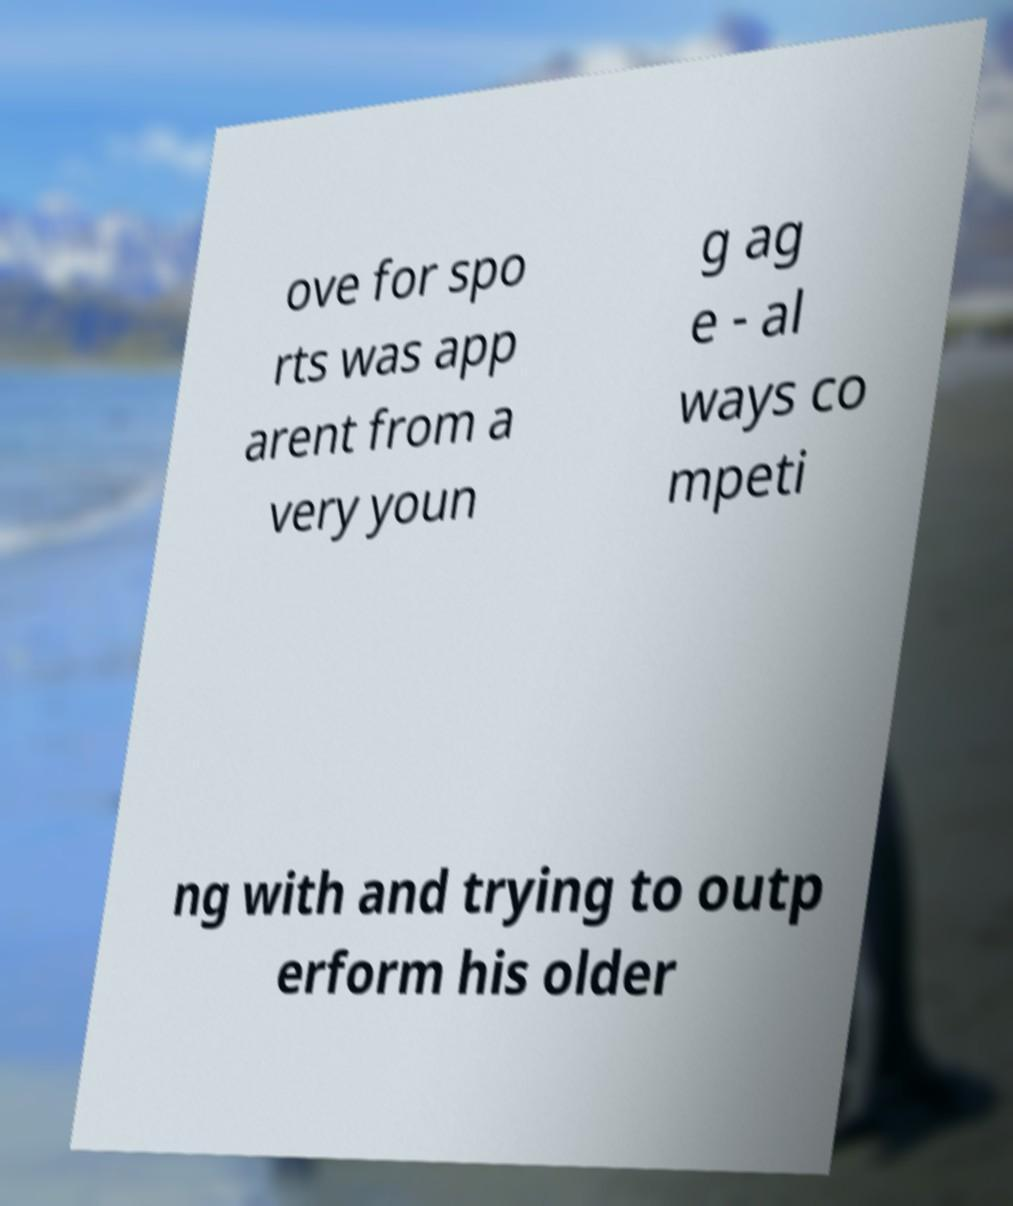Please read and relay the text visible in this image. What does it say? ove for spo rts was app arent from a very youn g ag e - al ways co mpeti ng with and trying to outp erform his older 